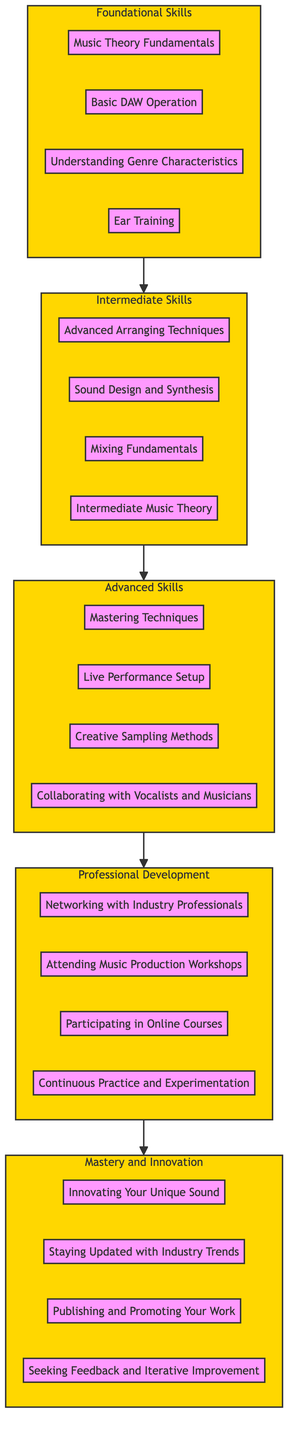What is the highest level in the flow chart? The diagram indicates five levels, with "Mastery and Innovation" as the highest level.
Answer: Mastery and Innovation How many items are listed under Intermediate Skills? The Intermediate Skills section contains four items: Advanced Arranging Techniques, Sound Design and Synthesis, Mixing Fundamentals, and Intermediate Music Theory.
Answer: 4 What skill follows "Basic DAW Operation" in the flow? The flow leads from Foundational Skills to Intermediate Skills, and "Basic DAW Operation" is followed by "Advanced Arranging Techniques."
Answer: Advanced Arranging Techniques Which level includes "Collaborating with Vocalists and Musicians"? "Collaborating with Vocalists and Musicians" is an item listed under the Advanced Skills level.
Answer: Advanced Skills What is the relationship between "Continuous Practice and Experimentation" and "Participating in Online Courses"? "Continuous Practice and Experimentation" is an item in the Professional Development level, which follows the Intermediate Skills level, and comes after "Participating in Online Courses."
Answer: Follows How many total items are in the Professional Development level? The Professional Development level contains four items: Networking with Industry Professionals, Attending Music Production Workshops, Participating in Online Courses, and Continuous Practice and Experimentation.
Answer: 4 What are the four end goals listed in the Mastery and Innovation level? The Mastery and Innovation level contains four goals: Innovating Your Unique Sound, Staying Updated with Industry Trends, Publishing and Promoting Your Work, and Seeking Feedback and Iterative Improvement.
Answer: Innovating Your Unique Sound, Staying Updated with Industry Trends, Publishing and Promoting Your Work, Seeking Feedback and Iterative Improvement What must be achieved before reaching Advanced Skills? Before reaching Advanced Skills, one must successfully complete both Foundational Skills and Intermediate Skills, which represent prerequisite levels.
Answer: Intermediate Skills What is the progression flow from Foundational Skills to Mastery and Innovation? The flow progresses from Foundational Skills to Intermediate Skills, then to Advanced Skills, continuing to Professional Development, and culminates in Mastery and Innovation.
Answer: Foundational Skills, Intermediate Skills, Advanced Skills, Professional Development, Mastery and Innovation 